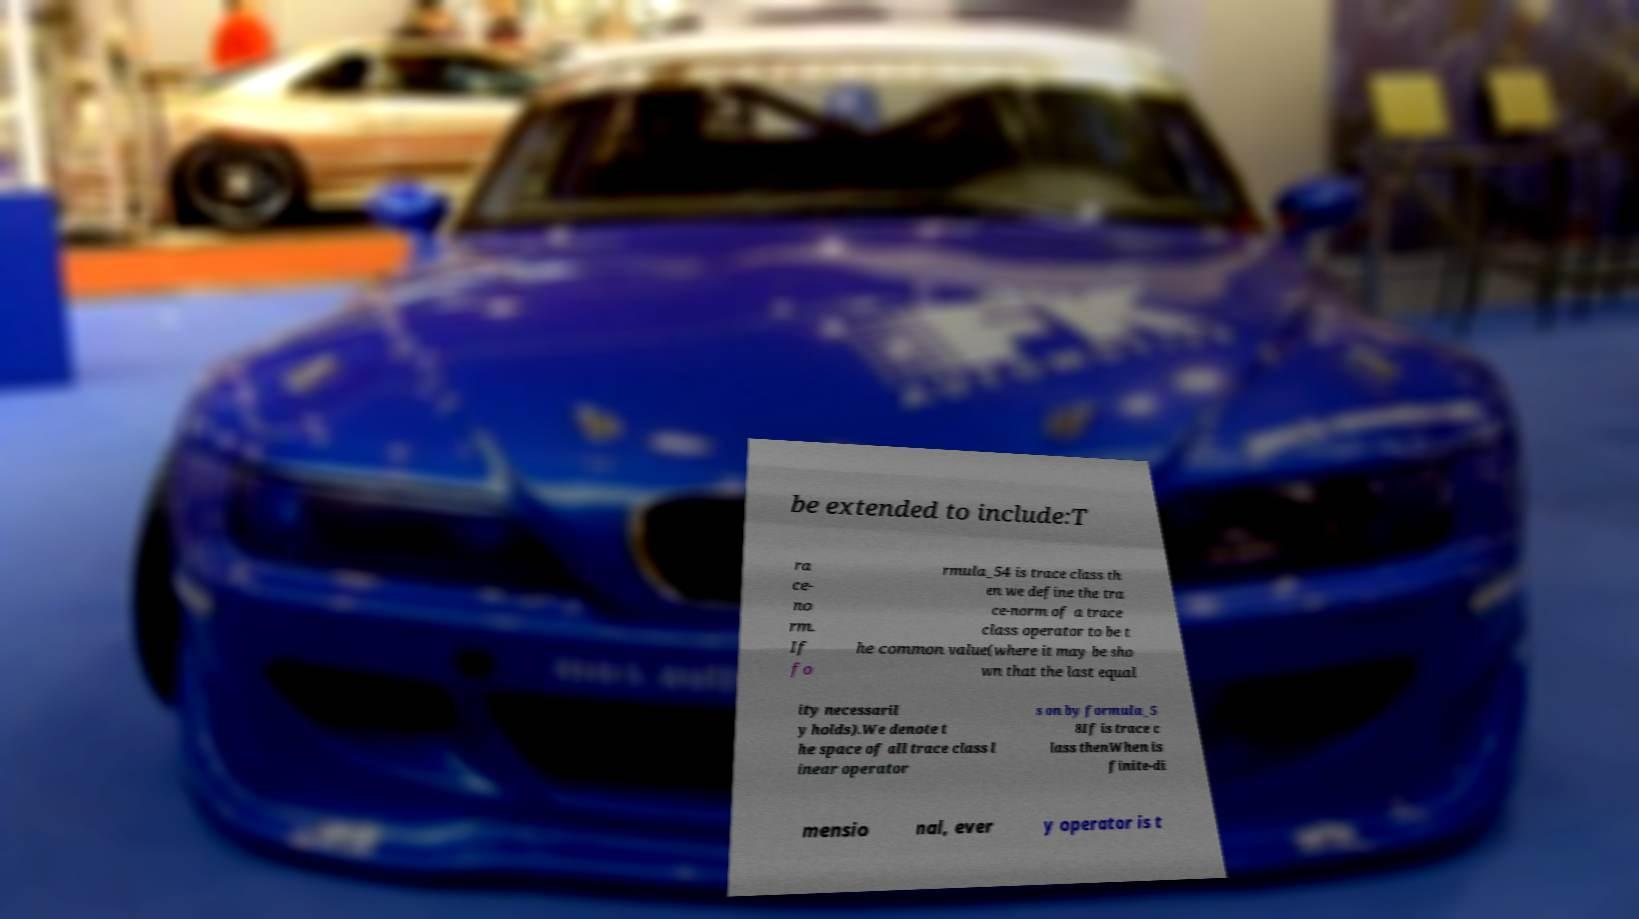Please read and relay the text visible in this image. What does it say? be extended to include:T ra ce- no rm. If fo rmula_54 is trace class th en we define the tra ce-norm of a trace class operator to be t he common value(where it may be sho wn that the last equal ity necessaril y holds).We denote t he space of all trace class l inear operator s on by formula_5 8If is trace c lass thenWhen is finite-di mensio nal, ever y operator is t 